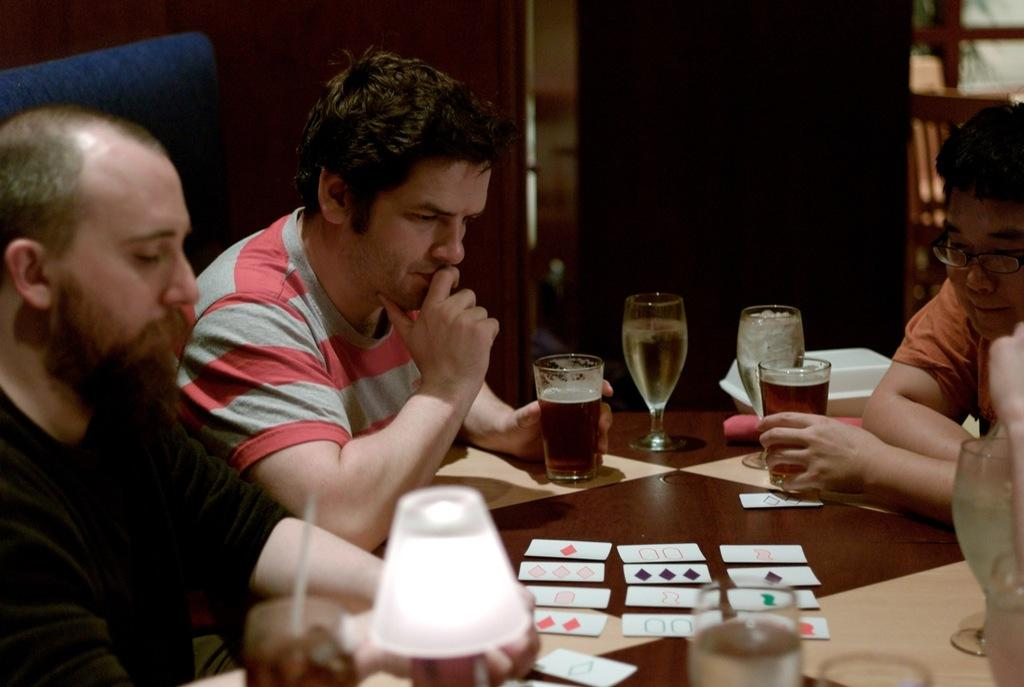How many people are in the image? There are three people in the image. What are the people doing in the image? The people are sitting on chairs. What is present on the table in the image? There are cards and glasses on the table. What might the people be using the cards for? The cards could be used for a game or activity. Can you see a ghost sitting on the bed in the image? There is no bed or ghost present in the image. What hobbies do the people in the image have? The provided facts do not give information about the hobbies of the people in the image. 